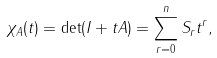<formula> <loc_0><loc_0><loc_500><loc_500>\chi _ { A } ( t ) = \det ( I + t A ) = \sum _ { r = 0 } ^ { n } S _ { r } t ^ { r } ,</formula> 